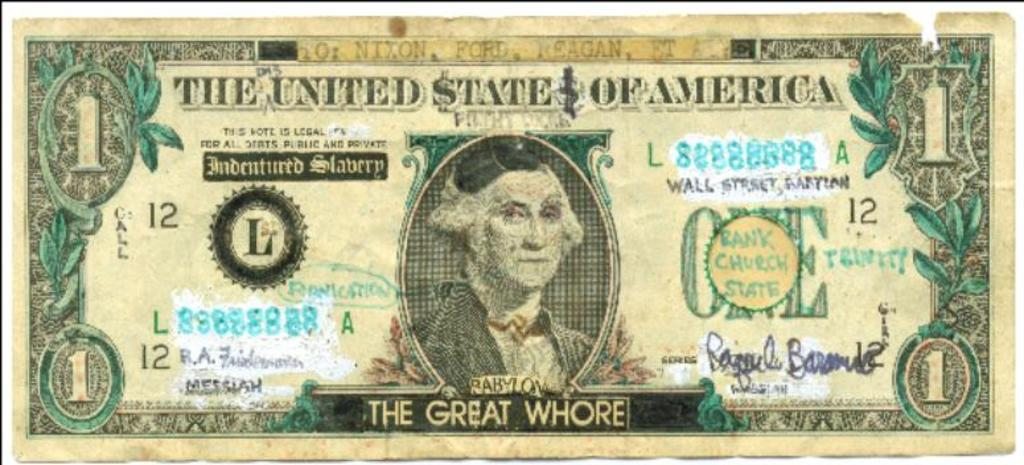Provide a one-sentence caption for the provided image. A one dollar bill from the United States of America. 